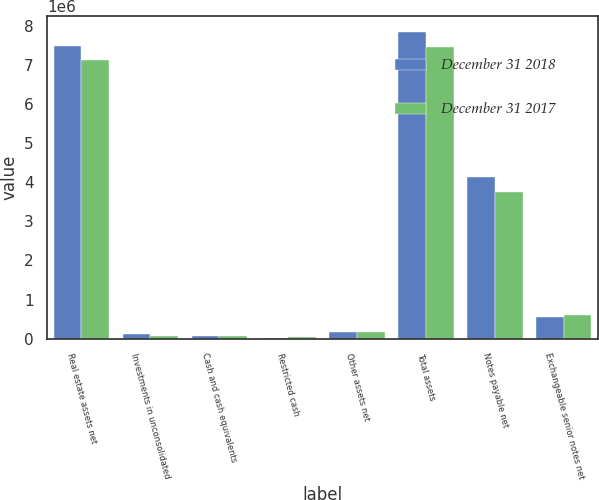Convert chart. <chart><loc_0><loc_0><loc_500><loc_500><stacked_bar_chart><ecel><fcel>Real estate assets net<fcel>Investments in unconsolidated<fcel>Cash and cash equivalents<fcel>Restricted cash<fcel>Other assets net<fcel>Total assets<fcel>Notes payable net<fcel>Exchangeable senior notes net<nl><fcel>December 31 2018<fcel>7.49183e+06<fcel>125326<fcel>57496<fcel>15194<fcel>158131<fcel>7.84798e+06<fcel>4.13721e+06<fcel>562374<nl><fcel>December 31 2017<fcel>7.13243e+06<fcel>75907<fcel>55683<fcel>30361<fcel>166571<fcel>7.46095e+06<fcel>3.7385e+06<fcel>604276<nl></chart> 